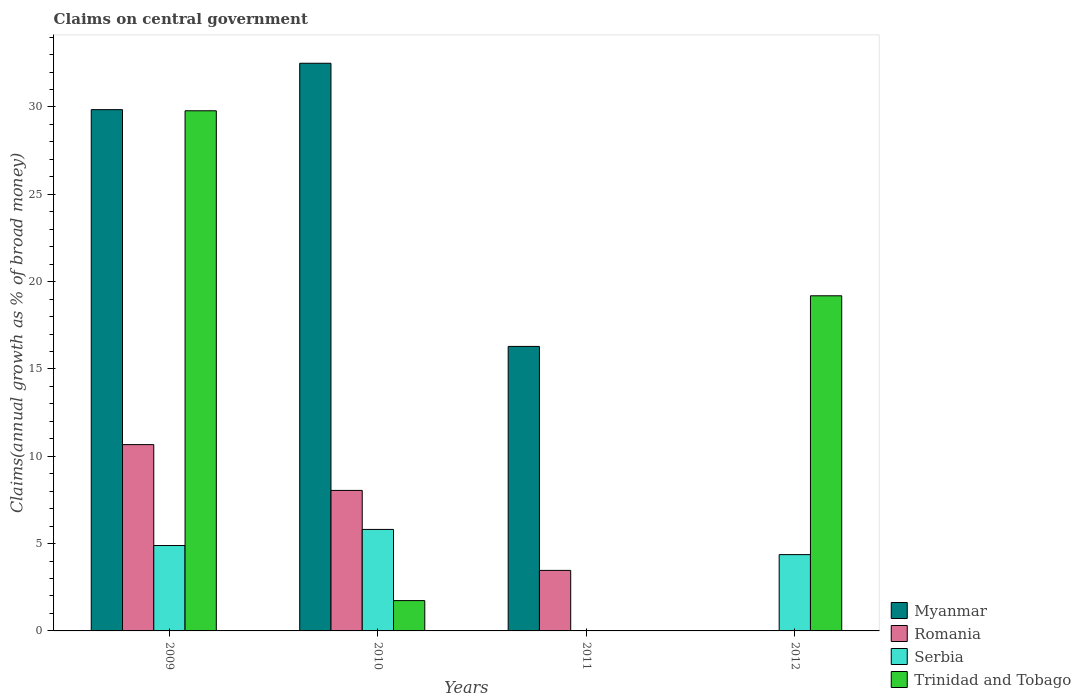Are the number of bars per tick equal to the number of legend labels?
Your response must be concise. No. Are the number of bars on each tick of the X-axis equal?
Your answer should be very brief. No. How many bars are there on the 4th tick from the left?
Your answer should be very brief. 2. What is the label of the 1st group of bars from the left?
Provide a short and direct response. 2009. In how many cases, is the number of bars for a given year not equal to the number of legend labels?
Offer a terse response. 2. What is the percentage of broad money claimed on centeral government in Romania in 2009?
Give a very brief answer. 10.67. Across all years, what is the maximum percentage of broad money claimed on centeral government in Trinidad and Tobago?
Give a very brief answer. 29.78. Across all years, what is the minimum percentage of broad money claimed on centeral government in Romania?
Your answer should be compact. 0. In which year was the percentage of broad money claimed on centeral government in Romania maximum?
Give a very brief answer. 2009. What is the total percentage of broad money claimed on centeral government in Romania in the graph?
Your response must be concise. 22.18. What is the difference between the percentage of broad money claimed on centeral government in Myanmar in 2009 and that in 2011?
Ensure brevity in your answer.  13.56. What is the difference between the percentage of broad money claimed on centeral government in Serbia in 2011 and the percentage of broad money claimed on centeral government in Romania in 2009?
Make the answer very short. -10.67. What is the average percentage of broad money claimed on centeral government in Myanmar per year?
Give a very brief answer. 19.66. In the year 2009, what is the difference between the percentage of broad money claimed on centeral government in Serbia and percentage of broad money claimed on centeral government in Trinidad and Tobago?
Make the answer very short. -24.89. In how many years, is the percentage of broad money claimed on centeral government in Trinidad and Tobago greater than 2 %?
Offer a terse response. 2. What is the ratio of the percentage of broad money claimed on centeral government in Serbia in 2010 to that in 2012?
Keep it short and to the point. 1.33. Is the difference between the percentage of broad money claimed on centeral government in Serbia in 2009 and 2012 greater than the difference between the percentage of broad money claimed on centeral government in Trinidad and Tobago in 2009 and 2012?
Offer a terse response. No. What is the difference between the highest and the second highest percentage of broad money claimed on centeral government in Serbia?
Offer a very short reply. 0.92. What is the difference between the highest and the lowest percentage of broad money claimed on centeral government in Serbia?
Offer a terse response. 5.81. Is the sum of the percentage of broad money claimed on centeral government in Romania in 2009 and 2011 greater than the maximum percentage of broad money claimed on centeral government in Serbia across all years?
Offer a terse response. Yes. How many bars are there?
Offer a terse response. 12. Are all the bars in the graph horizontal?
Give a very brief answer. No. Does the graph contain grids?
Your answer should be compact. No. How many legend labels are there?
Provide a short and direct response. 4. What is the title of the graph?
Your answer should be compact. Claims on central government. What is the label or title of the Y-axis?
Keep it short and to the point. Claims(annual growth as % of broad money). What is the Claims(annual growth as % of broad money) in Myanmar in 2009?
Offer a very short reply. 29.85. What is the Claims(annual growth as % of broad money) in Romania in 2009?
Offer a very short reply. 10.67. What is the Claims(annual growth as % of broad money) in Serbia in 2009?
Offer a very short reply. 4.89. What is the Claims(annual growth as % of broad money) in Trinidad and Tobago in 2009?
Give a very brief answer. 29.78. What is the Claims(annual growth as % of broad money) in Myanmar in 2010?
Offer a very short reply. 32.5. What is the Claims(annual growth as % of broad money) of Romania in 2010?
Your response must be concise. 8.05. What is the Claims(annual growth as % of broad money) of Serbia in 2010?
Offer a terse response. 5.81. What is the Claims(annual growth as % of broad money) of Trinidad and Tobago in 2010?
Your answer should be very brief. 1.74. What is the Claims(annual growth as % of broad money) in Myanmar in 2011?
Provide a short and direct response. 16.29. What is the Claims(annual growth as % of broad money) in Romania in 2011?
Offer a terse response. 3.47. What is the Claims(annual growth as % of broad money) in Serbia in 2011?
Ensure brevity in your answer.  0. What is the Claims(annual growth as % of broad money) in Serbia in 2012?
Offer a very short reply. 4.37. What is the Claims(annual growth as % of broad money) in Trinidad and Tobago in 2012?
Your response must be concise. 19.19. Across all years, what is the maximum Claims(annual growth as % of broad money) of Myanmar?
Keep it short and to the point. 32.5. Across all years, what is the maximum Claims(annual growth as % of broad money) of Romania?
Your response must be concise. 10.67. Across all years, what is the maximum Claims(annual growth as % of broad money) of Serbia?
Provide a succinct answer. 5.81. Across all years, what is the maximum Claims(annual growth as % of broad money) in Trinidad and Tobago?
Offer a terse response. 29.78. Across all years, what is the minimum Claims(annual growth as % of broad money) of Trinidad and Tobago?
Make the answer very short. 0. What is the total Claims(annual growth as % of broad money) of Myanmar in the graph?
Ensure brevity in your answer.  78.64. What is the total Claims(annual growth as % of broad money) in Romania in the graph?
Your response must be concise. 22.18. What is the total Claims(annual growth as % of broad money) in Serbia in the graph?
Provide a succinct answer. 15.07. What is the total Claims(annual growth as % of broad money) in Trinidad and Tobago in the graph?
Keep it short and to the point. 50.71. What is the difference between the Claims(annual growth as % of broad money) of Myanmar in 2009 and that in 2010?
Keep it short and to the point. -2.66. What is the difference between the Claims(annual growth as % of broad money) in Romania in 2009 and that in 2010?
Your response must be concise. 2.62. What is the difference between the Claims(annual growth as % of broad money) of Serbia in 2009 and that in 2010?
Offer a terse response. -0.92. What is the difference between the Claims(annual growth as % of broad money) of Trinidad and Tobago in 2009 and that in 2010?
Give a very brief answer. 28.05. What is the difference between the Claims(annual growth as % of broad money) in Myanmar in 2009 and that in 2011?
Give a very brief answer. 13.56. What is the difference between the Claims(annual growth as % of broad money) in Romania in 2009 and that in 2011?
Your answer should be compact. 7.2. What is the difference between the Claims(annual growth as % of broad money) of Serbia in 2009 and that in 2012?
Keep it short and to the point. 0.52. What is the difference between the Claims(annual growth as % of broad money) of Trinidad and Tobago in 2009 and that in 2012?
Offer a very short reply. 10.59. What is the difference between the Claims(annual growth as % of broad money) of Myanmar in 2010 and that in 2011?
Offer a terse response. 16.21. What is the difference between the Claims(annual growth as % of broad money) in Romania in 2010 and that in 2011?
Your answer should be very brief. 4.58. What is the difference between the Claims(annual growth as % of broad money) of Serbia in 2010 and that in 2012?
Your answer should be very brief. 1.44. What is the difference between the Claims(annual growth as % of broad money) in Trinidad and Tobago in 2010 and that in 2012?
Give a very brief answer. -17.45. What is the difference between the Claims(annual growth as % of broad money) in Myanmar in 2009 and the Claims(annual growth as % of broad money) in Romania in 2010?
Provide a short and direct response. 21.8. What is the difference between the Claims(annual growth as % of broad money) in Myanmar in 2009 and the Claims(annual growth as % of broad money) in Serbia in 2010?
Provide a short and direct response. 24.04. What is the difference between the Claims(annual growth as % of broad money) of Myanmar in 2009 and the Claims(annual growth as % of broad money) of Trinidad and Tobago in 2010?
Your answer should be very brief. 28.11. What is the difference between the Claims(annual growth as % of broad money) of Romania in 2009 and the Claims(annual growth as % of broad money) of Serbia in 2010?
Your response must be concise. 4.86. What is the difference between the Claims(annual growth as % of broad money) in Romania in 2009 and the Claims(annual growth as % of broad money) in Trinidad and Tobago in 2010?
Make the answer very short. 8.93. What is the difference between the Claims(annual growth as % of broad money) in Serbia in 2009 and the Claims(annual growth as % of broad money) in Trinidad and Tobago in 2010?
Offer a terse response. 3.15. What is the difference between the Claims(annual growth as % of broad money) of Myanmar in 2009 and the Claims(annual growth as % of broad money) of Romania in 2011?
Your answer should be compact. 26.38. What is the difference between the Claims(annual growth as % of broad money) of Myanmar in 2009 and the Claims(annual growth as % of broad money) of Serbia in 2012?
Offer a very short reply. 25.48. What is the difference between the Claims(annual growth as % of broad money) of Myanmar in 2009 and the Claims(annual growth as % of broad money) of Trinidad and Tobago in 2012?
Provide a succinct answer. 10.66. What is the difference between the Claims(annual growth as % of broad money) in Romania in 2009 and the Claims(annual growth as % of broad money) in Serbia in 2012?
Keep it short and to the point. 6.3. What is the difference between the Claims(annual growth as % of broad money) in Romania in 2009 and the Claims(annual growth as % of broad money) in Trinidad and Tobago in 2012?
Ensure brevity in your answer.  -8.52. What is the difference between the Claims(annual growth as % of broad money) of Serbia in 2009 and the Claims(annual growth as % of broad money) of Trinidad and Tobago in 2012?
Make the answer very short. -14.3. What is the difference between the Claims(annual growth as % of broad money) of Myanmar in 2010 and the Claims(annual growth as % of broad money) of Romania in 2011?
Ensure brevity in your answer.  29.04. What is the difference between the Claims(annual growth as % of broad money) of Myanmar in 2010 and the Claims(annual growth as % of broad money) of Serbia in 2012?
Your answer should be very brief. 28.14. What is the difference between the Claims(annual growth as % of broad money) of Myanmar in 2010 and the Claims(annual growth as % of broad money) of Trinidad and Tobago in 2012?
Offer a very short reply. 13.32. What is the difference between the Claims(annual growth as % of broad money) of Romania in 2010 and the Claims(annual growth as % of broad money) of Serbia in 2012?
Your response must be concise. 3.68. What is the difference between the Claims(annual growth as % of broad money) of Romania in 2010 and the Claims(annual growth as % of broad money) of Trinidad and Tobago in 2012?
Provide a succinct answer. -11.14. What is the difference between the Claims(annual growth as % of broad money) of Serbia in 2010 and the Claims(annual growth as % of broad money) of Trinidad and Tobago in 2012?
Your response must be concise. -13.38. What is the difference between the Claims(annual growth as % of broad money) in Myanmar in 2011 and the Claims(annual growth as % of broad money) in Serbia in 2012?
Your answer should be very brief. 11.92. What is the difference between the Claims(annual growth as % of broad money) of Myanmar in 2011 and the Claims(annual growth as % of broad money) of Trinidad and Tobago in 2012?
Ensure brevity in your answer.  -2.9. What is the difference between the Claims(annual growth as % of broad money) of Romania in 2011 and the Claims(annual growth as % of broad money) of Serbia in 2012?
Ensure brevity in your answer.  -0.9. What is the difference between the Claims(annual growth as % of broad money) of Romania in 2011 and the Claims(annual growth as % of broad money) of Trinidad and Tobago in 2012?
Make the answer very short. -15.72. What is the average Claims(annual growth as % of broad money) in Myanmar per year?
Offer a terse response. 19.66. What is the average Claims(annual growth as % of broad money) in Romania per year?
Offer a terse response. 5.54. What is the average Claims(annual growth as % of broad money) in Serbia per year?
Your response must be concise. 3.77. What is the average Claims(annual growth as % of broad money) of Trinidad and Tobago per year?
Offer a very short reply. 12.68. In the year 2009, what is the difference between the Claims(annual growth as % of broad money) in Myanmar and Claims(annual growth as % of broad money) in Romania?
Keep it short and to the point. 19.18. In the year 2009, what is the difference between the Claims(annual growth as % of broad money) of Myanmar and Claims(annual growth as % of broad money) of Serbia?
Provide a short and direct response. 24.96. In the year 2009, what is the difference between the Claims(annual growth as % of broad money) in Myanmar and Claims(annual growth as % of broad money) in Trinidad and Tobago?
Your answer should be compact. 0.06. In the year 2009, what is the difference between the Claims(annual growth as % of broad money) of Romania and Claims(annual growth as % of broad money) of Serbia?
Keep it short and to the point. 5.78. In the year 2009, what is the difference between the Claims(annual growth as % of broad money) in Romania and Claims(annual growth as % of broad money) in Trinidad and Tobago?
Ensure brevity in your answer.  -19.12. In the year 2009, what is the difference between the Claims(annual growth as % of broad money) in Serbia and Claims(annual growth as % of broad money) in Trinidad and Tobago?
Your answer should be very brief. -24.89. In the year 2010, what is the difference between the Claims(annual growth as % of broad money) in Myanmar and Claims(annual growth as % of broad money) in Romania?
Your answer should be very brief. 24.46. In the year 2010, what is the difference between the Claims(annual growth as % of broad money) of Myanmar and Claims(annual growth as % of broad money) of Serbia?
Give a very brief answer. 26.69. In the year 2010, what is the difference between the Claims(annual growth as % of broad money) in Myanmar and Claims(annual growth as % of broad money) in Trinidad and Tobago?
Keep it short and to the point. 30.77. In the year 2010, what is the difference between the Claims(annual growth as % of broad money) in Romania and Claims(annual growth as % of broad money) in Serbia?
Offer a terse response. 2.23. In the year 2010, what is the difference between the Claims(annual growth as % of broad money) in Romania and Claims(annual growth as % of broad money) in Trinidad and Tobago?
Your answer should be compact. 6.31. In the year 2010, what is the difference between the Claims(annual growth as % of broad money) of Serbia and Claims(annual growth as % of broad money) of Trinidad and Tobago?
Your answer should be compact. 4.08. In the year 2011, what is the difference between the Claims(annual growth as % of broad money) of Myanmar and Claims(annual growth as % of broad money) of Romania?
Offer a very short reply. 12.83. In the year 2012, what is the difference between the Claims(annual growth as % of broad money) of Serbia and Claims(annual growth as % of broad money) of Trinidad and Tobago?
Give a very brief answer. -14.82. What is the ratio of the Claims(annual growth as % of broad money) of Myanmar in 2009 to that in 2010?
Give a very brief answer. 0.92. What is the ratio of the Claims(annual growth as % of broad money) in Romania in 2009 to that in 2010?
Provide a succinct answer. 1.33. What is the ratio of the Claims(annual growth as % of broad money) in Serbia in 2009 to that in 2010?
Your response must be concise. 0.84. What is the ratio of the Claims(annual growth as % of broad money) in Trinidad and Tobago in 2009 to that in 2010?
Ensure brevity in your answer.  17.15. What is the ratio of the Claims(annual growth as % of broad money) of Myanmar in 2009 to that in 2011?
Your response must be concise. 1.83. What is the ratio of the Claims(annual growth as % of broad money) of Romania in 2009 to that in 2011?
Your answer should be compact. 3.08. What is the ratio of the Claims(annual growth as % of broad money) of Serbia in 2009 to that in 2012?
Offer a terse response. 1.12. What is the ratio of the Claims(annual growth as % of broad money) in Trinidad and Tobago in 2009 to that in 2012?
Offer a very short reply. 1.55. What is the ratio of the Claims(annual growth as % of broad money) of Myanmar in 2010 to that in 2011?
Provide a succinct answer. 2. What is the ratio of the Claims(annual growth as % of broad money) in Romania in 2010 to that in 2011?
Your answer should be compact. 2.32. What is the ratio of the Claims(annual growth as % of broad money) of Serbia in 2010 to that in 2012?
Ensure brevity in your answer.  1.33. What is the ratio of the Claims(annual growth as % of broad money) in Trinidad and Tobago in 2010 to that in 2012?
Make the answer very short. 0.09. What is the difference between the highest and the second highest Claims(annual growth as % of broad money) of Myanmar?
Offer a very short reply. 2.66. What is the difference between the highest and the second highest Claims(annual growth as % of broad money) of Romania?
Make the answer very short. 2.62. What is the difference between the highest and the second highest Claims(annual growth as % of broad money) of Serbia?
Ensure brevity in your answer.  0.92. What is the difference between the highest and the second highest Claims(annual growth as % of broad money) in Trinidad and Tobago?
Your answer should be compact. 10.59. What is the difference between the highest and the lowest Claims(annual growth as % of broad money) in Myanmar?
Keep it short and to the point. 32.5. What is the difference between the highest and the lowest Claims(annual growth as % of broad money) in Romania?
Offer a terse response. 10.67. What is the difference between the highest and the lowest Claims(annual growth as % of broad money) of Serbia?
Ensure brevity in your answer.  5.81. What is the difference between the highest and the lowest Claims(annual growth as % of broad money) in Trinidad and Tobago?
Ensure brevity in your answer.  29.78. 